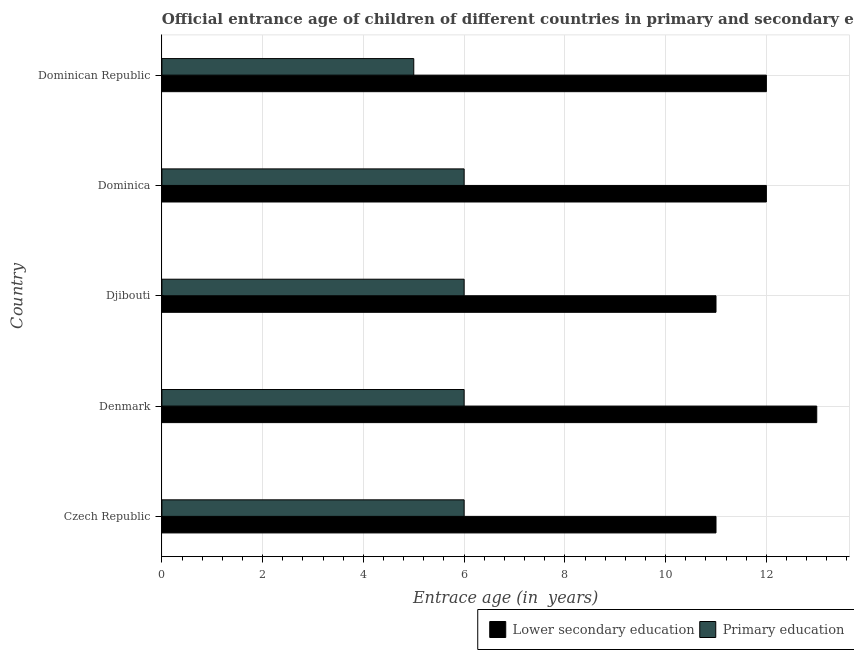How many groups of bars are there?
Offer a terse response. 5. Are the number of bars per tick equal to the number of legend labels?
Your answer should be very brief. Yes. How many bars are there on the 3rd tick from the top?
Keep it short and to the point. 2. What is the label of the 5th group of bars from the top?
Ensure brevity in your answer.  Czech Republic. What is the entrance age of children in lower secondary education in Czech Republic?
Ensure brevity in your answer.  11. Across all countries, what is the minimum entrance age of children in lower secondary education?
Make the answer very short. 11. In which country was the entrance age of chiildren in primary education maximum?
Offer a terse response. Czech Republic. In which country was the entrance age of chiildren in primary education minimum?
Your answer should be very brief. Dominican Republic. What is the total entrance age of chiildren in primary education in the graph?
Ensure brevity in your answer.  29. What is the difference between the entrance age of chiildren in primary education in Czech Republic and that in Dominica?
Offer a terse response. 0. What is the difference between the entrance age of chiildren in primary education in Djibouti and the entrance age of children in lower secondary education in Denmark?
Offer a terse response. -7. What is the average entrance age of chiildren in primary education per country?
Offer a terse response. 5.8. What is the difference between the entrance age of chiildren in primary education and entrance age of children in lower secondary education in Dominican Republic?
Your response must be concise. -7. In how many countries, is the entrance age of children in lower secondary education greater than 7.6 years?
Your answer should be compact. 5. Is the entrance age of chiildren in primary education in Denmark less than that in Dominica?
Ensure brevity in your answer.  No. What is the difference between the highest and the second highest entrance age of children in lower secondary education?
Your answer should be very brief. 1. What is the difference between the highest and the lowest entrance age of chiildren in primary education?
Offer a terse response. 1. In how many countries, is the entrance age of children in lower secondary education greater than the average entrance age of children in lower secondary education taken over all countries?
Offer a terse response. 3. What does the 2nd bar from the top in Dominica represents?
Make the answer very short. Lower secondary education. What does the 1st bar from the bottom in Djibouti represents?
Keep it short and to the point. Lower secondary education. How many bars are there?
Your answer should be compact. 10. Are all the bars in the graph horizontal?
Give a very brief answer. Yes. How many countries are there in the graph?
Your answer should be compact. 5. What is the difference between two consecutive major ticks on the X-axis?
Your response must be concise. 2. Does the graph contain any zero values?
Your answer should be compact. No. What is the title of the graph?
Your answer should be compact. Official entrance age of children of different countries in primary and secondary education. What is the label or title of the X-axis?
Your answer should be compact. Entrace age (in  years). What is the Entrace age (in  years) of Lower secondary education in Czech Republic?
Offer a terse response. 11. What is the Entrace age (in  years) in Primary education in Dominica?
Your answer should be compact. 6. What is the Entrace age (in  years) in Lower secondary education in Dominican Republic?
Provide a short and direct response. 12. Across all countries, what is the minimum Entrace age (in  years) of Lower secondary education?
Give a very brief answer. 11. Across all countries, what is the minimum Entrace age (in  years) of Primary education?
Provide a succinct answer. 5. What is the total Entrace age (in  years) in Lower secondary education in the graph?
Keep it short and to the point. 59. What is the total Entrace age (in  years) of Primary education in the graph?
Give a very brief answer. 29. What is the difference between the Entrace age (in  years) in Lower secondary education in Czech Republic and that in Denmark?
Keep it short and to the point. -2. What is the difference between the Entrace age (in  years) in Lower secondary education in Czech Republic and that in Dominica?
Provide a short and direct response. -1. What is the difference between the Entrace age (in  years) of Primary education in Czech Republic and that in Dominica?
Keep it short and to the point. 0. What is the difference between the Entrace age (in  years) in Primary education in Czech Republic and that in Dominican Republic?
Ensure brevity in your answer.  1. What is the difference between the Entrace age (in  years) of Lower secondary education in Denmark and that in Djibouti?
Provide a short and direct response. 2. What is the difference between the Entrace age (in  years) in Primary education in Denmark and that in Dominica?
Offer a terse response. 0. What is the difference between the Entrace age (in  years) of Lower secondary education in Djibouti and that in Dominica?
Offer a terse response. -1. What is the difference between the Entrace age (in  years) of Primary education in Djibouti and that in Dominican Republic?
Keep it short and to the point. 1. What is the difference between the Entrace age (in  years) of Primary education in Dominica and that in Dominican Republic?
Provide a succinct answer. 1. What is the difference between the Entrace age (in  years) in Lower secondary education in Czech Republic and the Entrace age (in  years) in Primary education in Dominican Republic?
Provide a short and direct response. 6. What is the difference between the Entrace age (in  years) of Lower secondary education in Denmark and the Entrace age (in  years) of Primary education in Dominica?
Provide a short and direct response. 7. What is the difference between the Entrace age (in  years) of Lower secondary education in Denmark and the Entrace age (in  years) of Primary education in Dominican Republic?
Provide a short and direct response. 8. What is the difference between the Entrace age (in  years) of Lower secondary education in Djibouti and the Entrace age (in  years) of Primary education in Dominican Republic?
Make the answer very short. 6. What is the difference between the Entrace age (in  years) in Lower secondary education in Dominica and the Entrace age (in  years) in Primary education in Dominican Republic?
Offer a terse response. 7. What is the average Entrace age (in  years) of Lower secondary education per country?
Make the answer very short. 11.8. What is the difference between the Entrace age (in  years) of Lower secondary education and Entrace age (in  years) of Primary education in Czech Republic?
Provide a short and direct response. 5. What is the difference between the Entrace age (in  years) of Lower secondary education and Entrace age (in  years) of Primary education in Djibouti?
Provide a succinct answer. 5. What is the difference between the Entrace age (in  years) of Lower secondary education and Entrace age (in  years) of Primary education in Dominica?
Keep it short and to the point. 6. What is the ratio of the Entrace age (in  years) of Lower secondary education in Czech Republic to that in Denmark?
Provide a succinct answer. 0.85. What is the ratio of the Entrace age (in  years) in Primary education in Czech Republic to that in Djibouti?
Provide a succinct answer. 1. What is the ratio of the Entrace age (in  years) of Lower secondary education in Czech Republic to that in Dominica?
Keep it short and to the point. 0.92. What is the ratio of the Entrace age (in  years) in Lower secondary education in Czech Republic to that in Dominican Republic?
Make the answer very short. 0.92. What is the ratio of the Entrace age (in  years) in Lower secondary education in Denmark to that in Djibouti?
Your answer should be very brief. 1.18. What is the ratio of the Entrace age (in  years) of Primary education in Denmark to that in Djibouti?
Provide a succinct answer. 1. What is the ratio of the Entrace age (in  years) of Primary education in Denmark to that in Dominica?
Offer a very short reply. 1. What is the ratio of the Entrace age (in  years) in Lower secondary education in Denmark to that in Dominican Republic?
Give a very brief answer. 1.08. What is the ratio of the Entrace age (in  years) in Primary education in Denmark to that in Dominican Republic?
Keep it short and to the point. 1.2. What is the ratio of the Entrace age (in  years) in Lower secondary education in Djibouti to that in Dominican Republic?
Make the answer very short. 0.92. What is the ratio of the Entrace age (in  years) in Lower secondary education in Dominica to that in Dominican Republic?
Give a very brief answer. 1. What is the difference between the highest and the lowest Entrace age (in  years) of Primary education?
Provide a short and direct response. 1. 